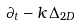Convert formula to latex. <formula><loc_0><loc_0><loc_500><loc_500>\partial _ { t } - k \, \Delta _ { 2 D }</formula> 